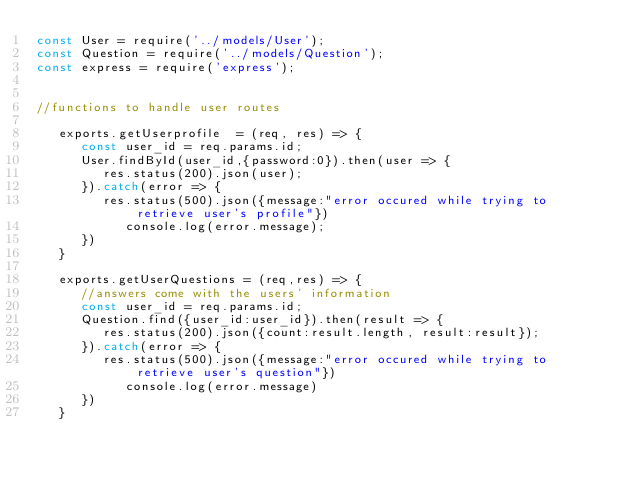<code> <loc_0><loc_0><loc_500><loc_500><_JavaScript_>const User = require('../models/User');
const Question = require('../models/Question');
const express = require('express');


//functions to handle user routes

   exports.getUserprofile  = (req, res) => {
      const user_id = req.params.id;
      User.findById(user_id,{password:0}).then(user => {
         res.status(200).json(user);
      }).catch(error => {
         res.status(500).json({message:"error occured while trying to retrieve user's profile"})
            console.log(error.message);
      })
   }

   exports.getUserQuestions = (req,res) => {
      //answers come with the users' information 
      const user_id = req.params.id;
      Question.find({user_id:user_id}).then(result => {
         res.status(200).json({count:result.length, result:result});
      }).catch(error => {
         res.status(500).json({message:"error occured while trying to retrieve user's question"})
            console.log(error.message)
      })
   }

</code> 